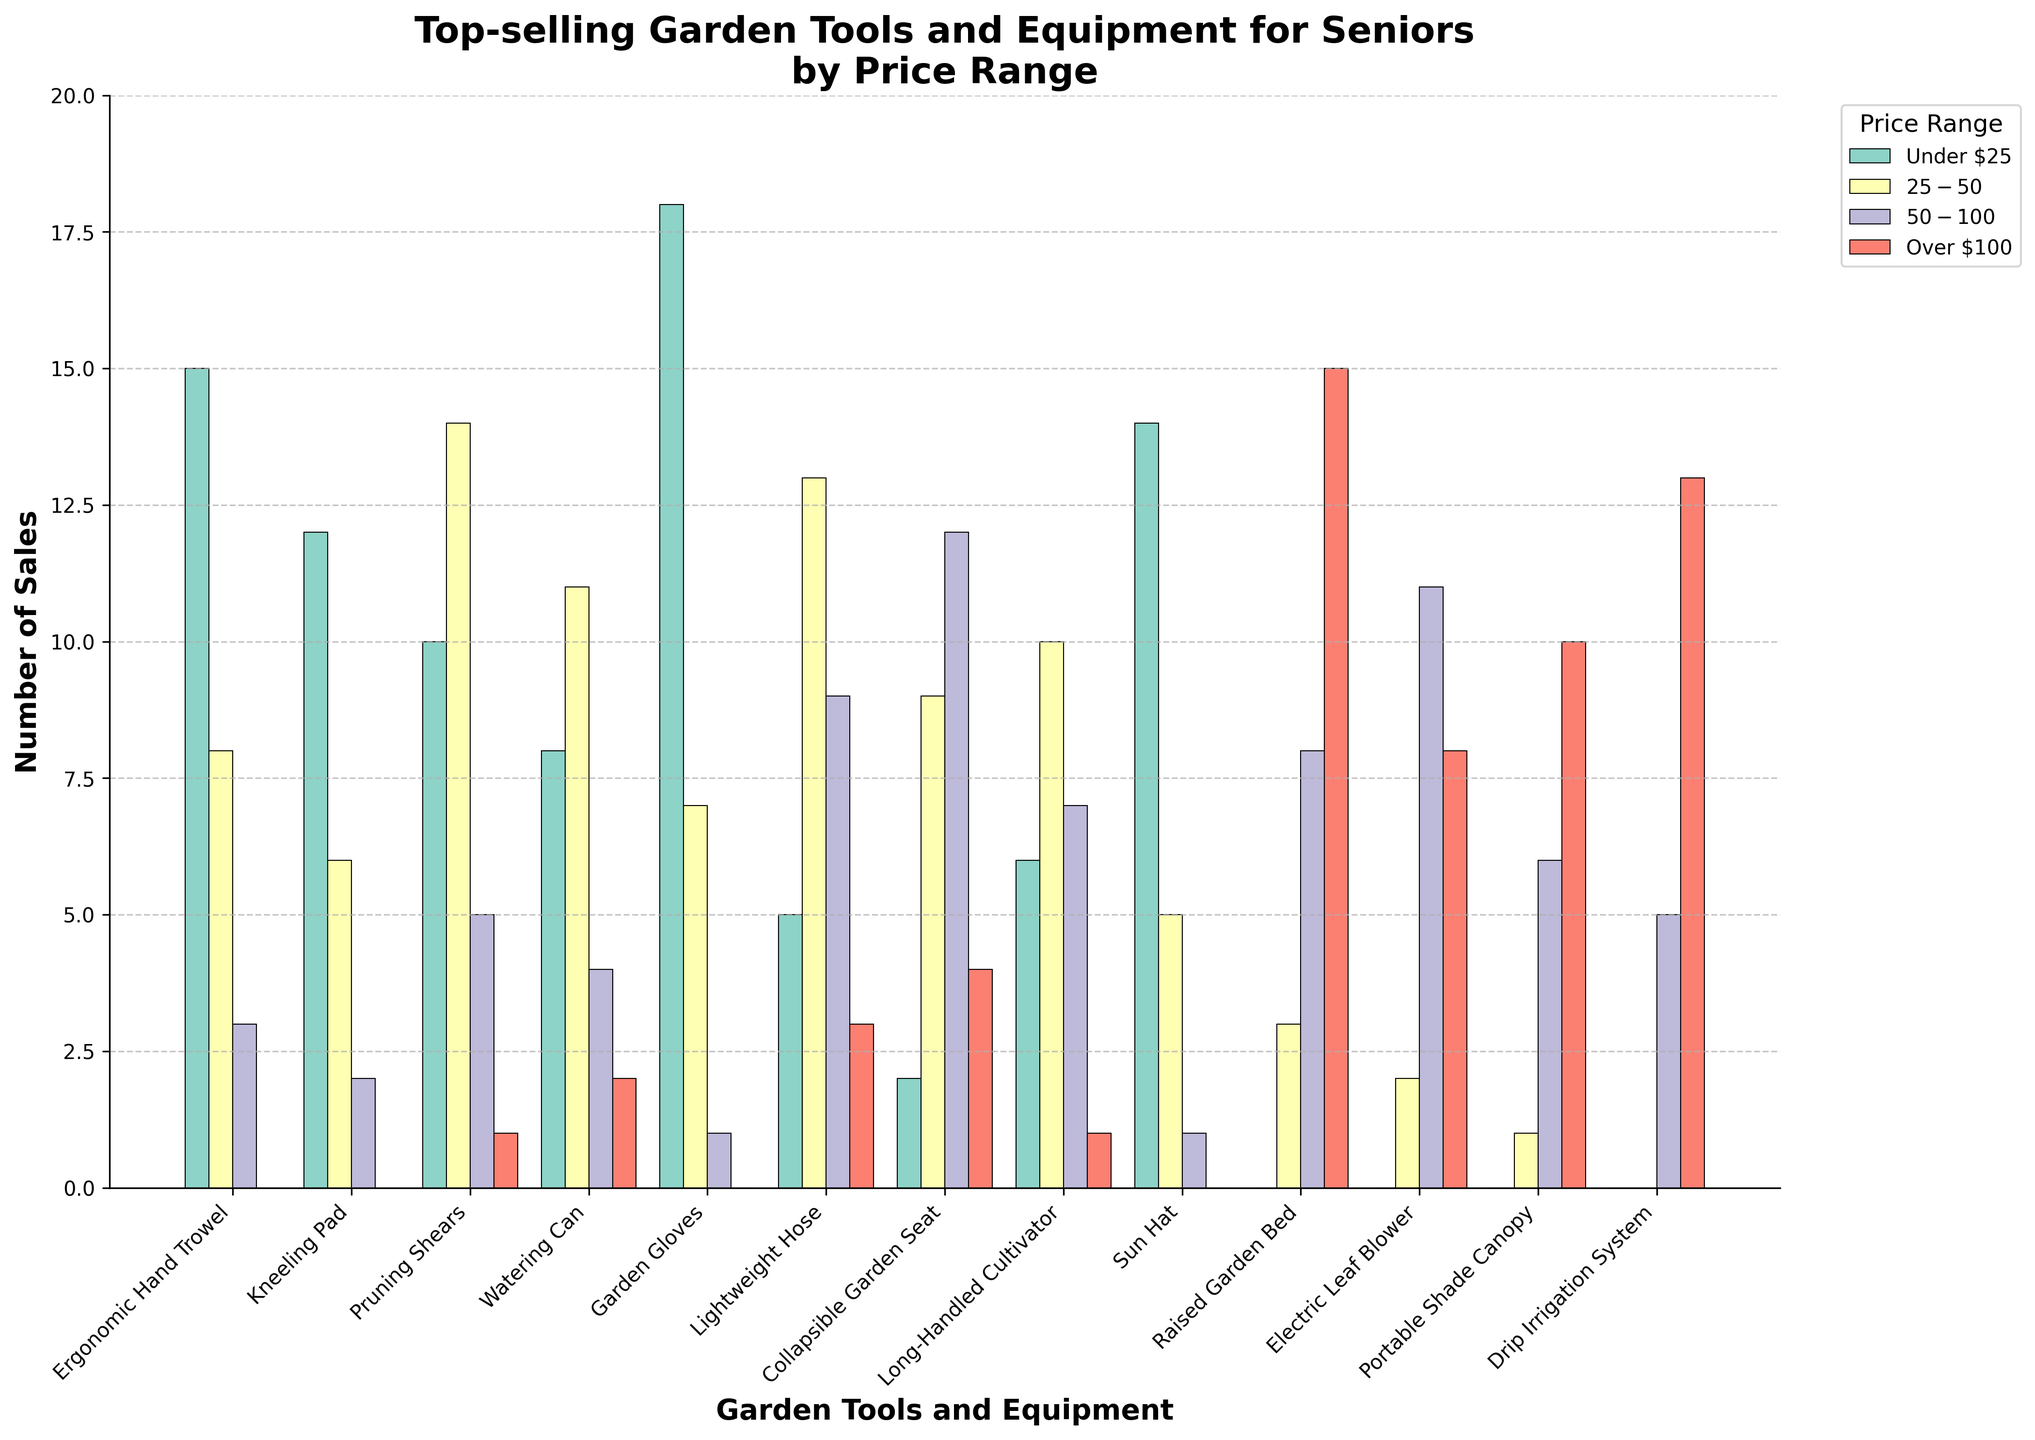What are the top two garden tools and equipment categories with the highest sales in the "Under $25" price range? The highest bars under the "Under $25" price range represent Garden Gloves and Ergonomic Hand Trowel, as they have the highest values in that range, specifically 18 and 15, respectively.
Answer: Garden Gloves and Ergonomic Hand Trowel Which garden tool has more total sales: the Pruning Shears or the Electric Leaf Blower? Summing the sales for Pruning Shears across all price ranges gives 10 + 14 + 5 + 1 = 30. For the Electric Leaf Blower, the total sales are 0 + 2 + 11 + 8 = 21. Therefore, Pruning Shears has more total sales.
Answer: Pruning Shears How many tools have their highest sales in the "$50-$100" price range? The highest bars for each tool can be identified: (Ergonomic Hand Trowel - Under $25), (Kneeling Pad - Under $25), (Pruning Shears - $25-$50), (Watering Can - $25-$50), (Garden Gloves - Under $25), (Lightweight Hose - $25-$50), (Collapsible Garden Seat - $50-$100), (Long-Handled Cultivator - $25-$50), (Sun Hat - Under $25), (Raised Garden Bed - Over $100), (Electric Leaf Blower - $50-$100), (Portable Shade Canopy - Over $100), (Drip Irrigation System - Over $100). Only the Collapsible Garden Seat and Electric Leaf Blower have their highest sales in the "$50-$100" price range.
Answer: 2 Which category shows the most sales in the "Over $100" price range? The bar representing the Raised Garden Bed in the "Over $100" price range is the tallest, indicating it has the highest sales (15) in that price range compared to other categories.
Answer: Raised Garden Bed What is the total number of sales for the Long-Handled Cultivator across all price ranges? Adding the sales for Long-Handled Cultivator across all price ranges: 6 (Under $25) + 10 ($25-$50) + 7 ($50-$100) + 1 (Over $100) = 24.
Answer: 24 How do the combined sales of the Ergonomic Hand Trowel and Garden Gloves compare to the total sales of the Raised Garden Bed? Summing up the sales of the Ergonomic Hand Trowel: 15 + 8 + 3 + 0 = 26, and the sales for Garden Gloves: 18 + 7 + 1 + 0 = 26. Combined, their total sales are 26 + 26 = 52. The Raised Garden Bed's total sales are 0 + 3 + 8 + 15 = 26. Therefore, combined sales of Ergonomic Hand Trowel and Garden Gloves (52) exceed the total sales of the Raised Garden Bed (26).
Answer: Combined sales of Ergonomic Hand Trowel and Garden Gloves are higher Which price range is the most popular for purchasing a Portable Shade Canopy? The highest bar for the Portable Shade Canopy is in the "Over $100" price range with 10 sales, making it the most popular price range for this category.
Answer: Over $100 